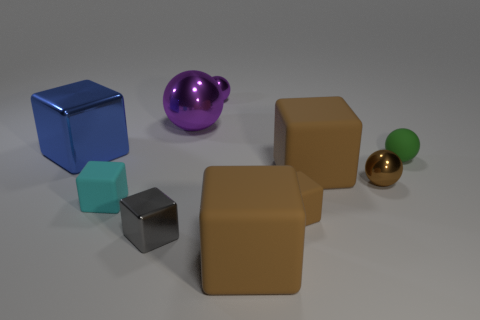The brown metal thing is what size?
Your answer should be compact. Small. Is there a tiny shiny thing that has the same color as the big shiny ball?
Keep it short and to the point. Yes. What number of large things are either green matte cubes or rubber cubes?
Keep it short and to the point. 2. How big is the cube that is both behind the cyan rubber block and to the right of the blue cube?
Keep it short and to the point. Large. There is a tiny brown metal object; what number of small objects are left of it?
Your answer should be very brief. 4. What is the shape of the tiny metallic object that is both on the left side of the brown metal ball and behind the tiny gray thing?
Provide a succinct answer. Sphere. What material is the thing that is the same color as the big metallic ball?
Make the answer very short. Metal. How many blocks are either big cyan things or gray shiny things?
Ensure brevity in your answer.  1. There is another metal sphere that is the same color as the large shiny sphere; what is its size?
Make the answer very short. Small. Are there fewer brown objects behind the small metallic block than tiny red rubber things?
Make the answer very short. No. 